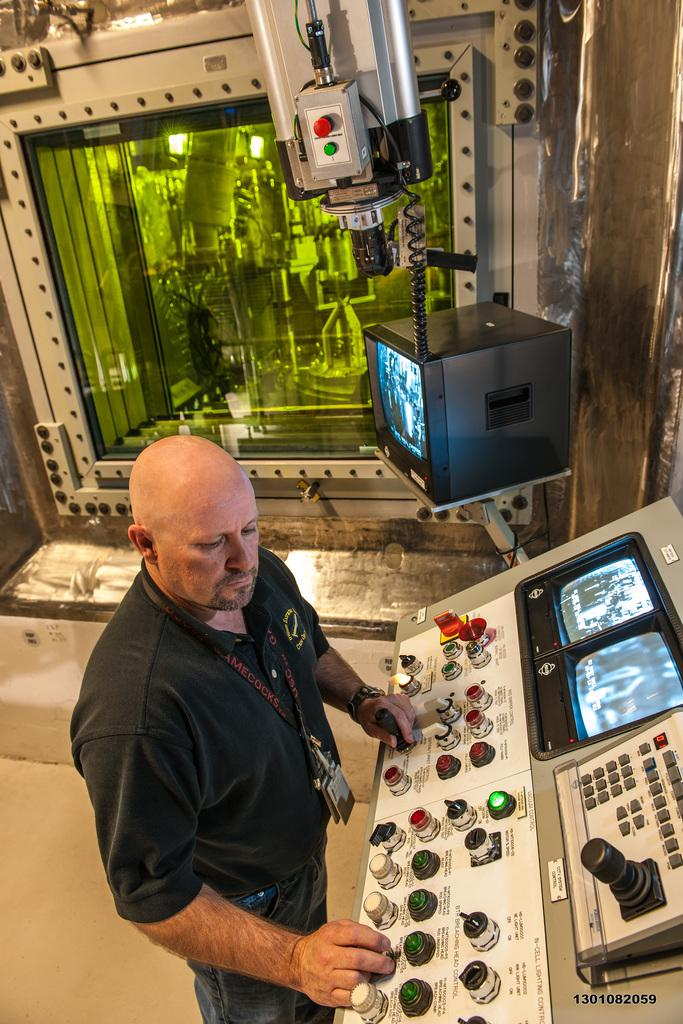What is the person in the image doing? The person is operating a machine. What is the person wearing in the image? The person is wearing a black t-shirt and an ID card. What is in front of the person? There are buttons and a screen in front of the person. What is at the back of the person? There is a screen and a machine at the back of the person. What type of cracker is being used to operate the machine in the image? There is no cracker present in the image; the person is operating the machine using their hands. How does the person express disgust while operating the machine in the image? There is no indication of disgust in the image; the person appears to be focused on operating the machine. 